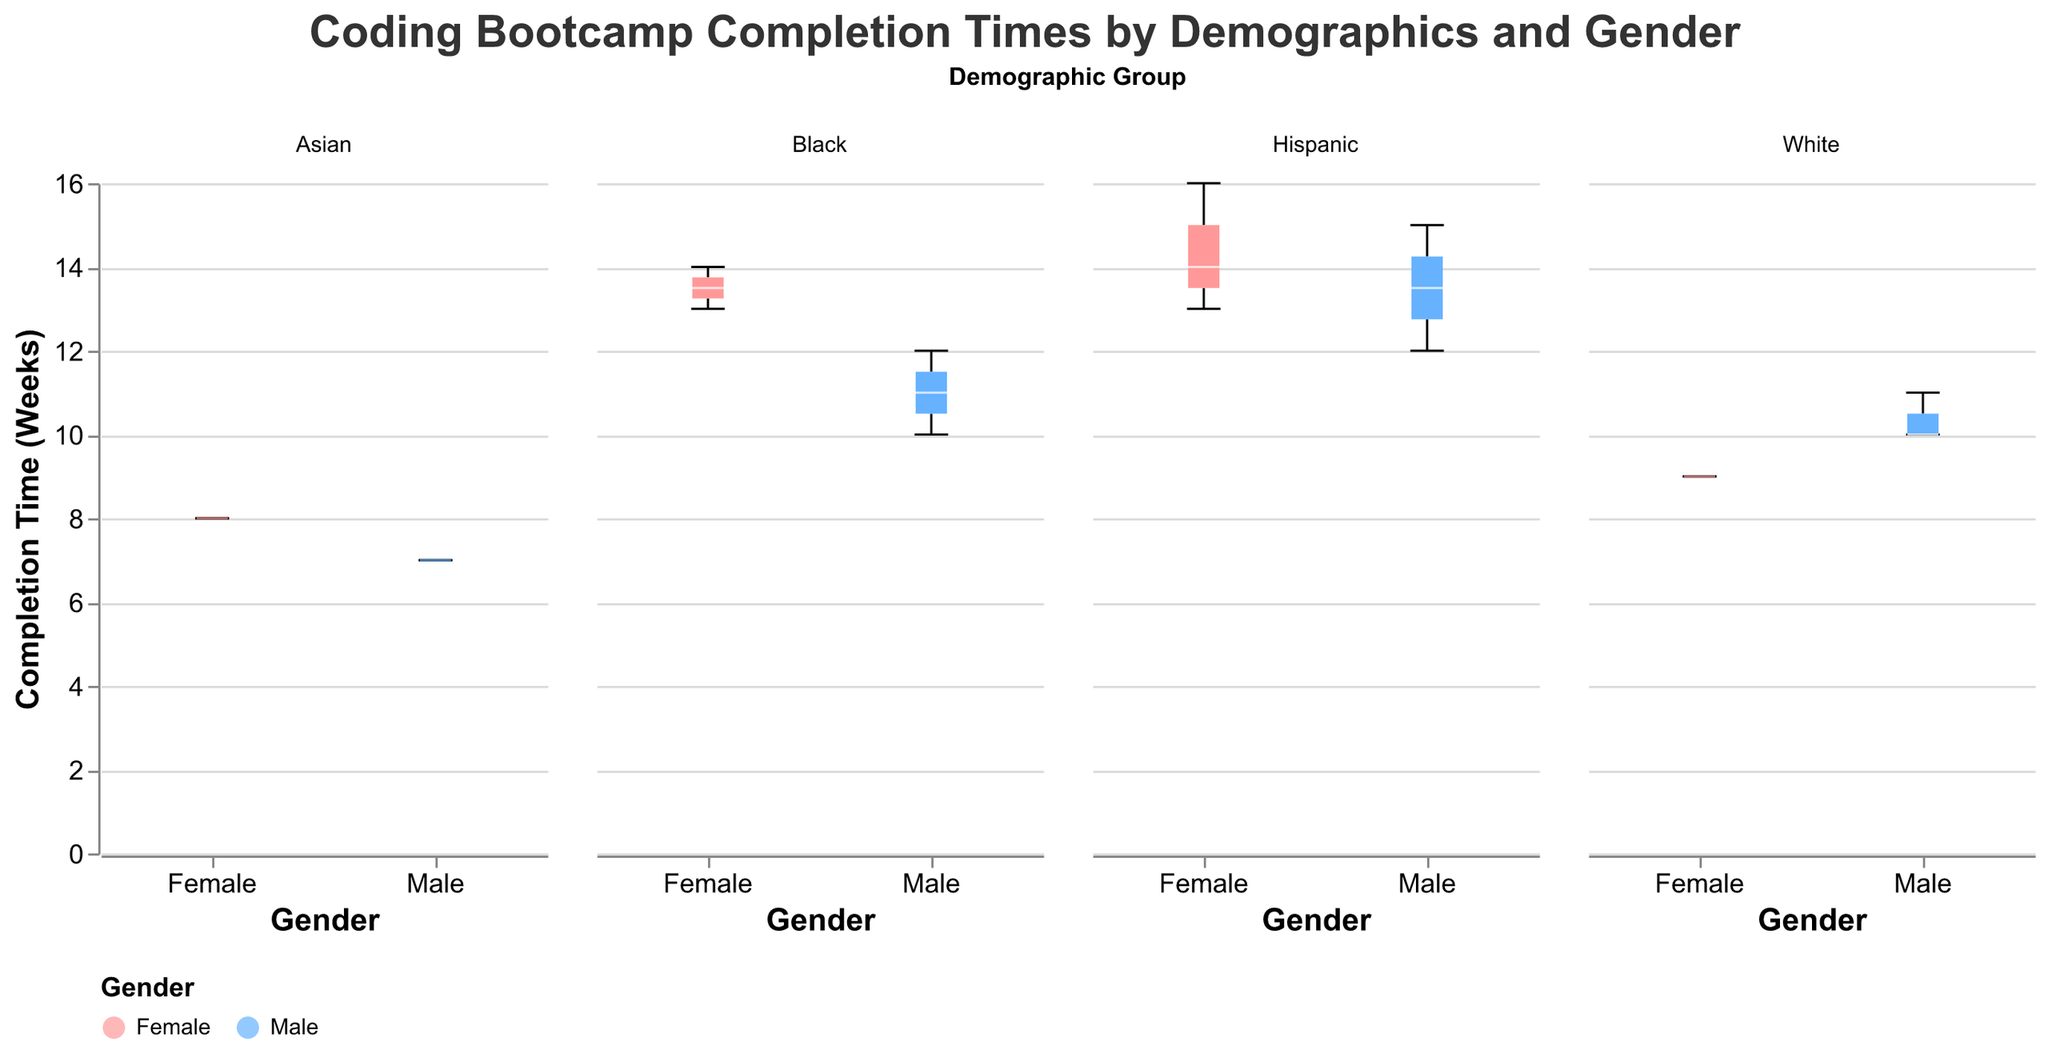What is the title of the figure? The figure's title is clearly positioned at the top and reads "Coding Bootcamp Completion Times by Demographics and Gender."
Answer: Coding Bootcamp Completion Times by Demographics and Gender What are the x-axis and y-axis labels? The x-axis is labeled "Gender" and categorizes the data into Male and Female. The y-axis is labeled "Completion Time (Weeks)" and shows the number of weeks to complete the bootcamp.
Answer: Gender, Completion Time (Weeks) Which demographic group has the widest range of completion times? The range of completion times can be determined by the length of the boxplots. Hispanic demographic shows the widest range because its boxplot spans from around 12 weeks to nearly 16 weeks.
Answer: Hispanic In the White demographic, which gender has a longer median completion time? The median is indicated by the white line in the boxplot. In the White demographic, the median for Males is 10 weeks and for Females is 9 weeks.
Answer: Male Which gender shows the shortest range of completion times in the Asian demographic? The range of completion times is indicated by the length of each boxplot. For the Asian demographic, both Male and Female groups show a similar range, approximately spanning from 7 to 8 weeks.
Answer: Similar range What is the median completion time for the General Assembly bootcamp in the Black demographic? We refer to the General Assembly boxplot, where the white line (median) is at 12 weeks.
Answer: 12 weeks By how many weeks does the median completion time of Hispanic males exceed that of Hispanic females? The median of Hispanic males is 12 weeks, while the median for Hispanic females is 14 weeks. The difference is calculated as 14 - 12 = 2 weeks.
Answer: 2 weeks Which demographic shows a higher variability in completion times, Black or Asian? To compare variability, we look at the length of the boxplots. The Black demographic has completion times ranging from 10 to around 14 weeks, while the Asian demographic completion time ranges from 7 to around 8 weeks. The Black demographic shows higher variability.
Answer: Black Among all the demographic groups, which demographic has the shortest median completion time? From the visual inspection of median lines across different demographics, the shortest median completion time is found in the Asian demographic at 8 weeks.
Answer: Asian 